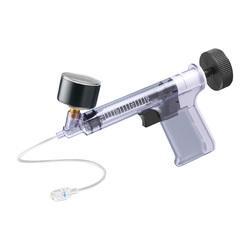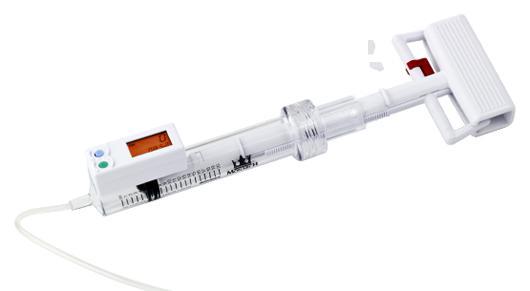The first image is the image on the left, the second image is the image on the right. Considering the images on both sides, is "At least 1 device has a red stripe above it." valid? Answer yes or no. No. 